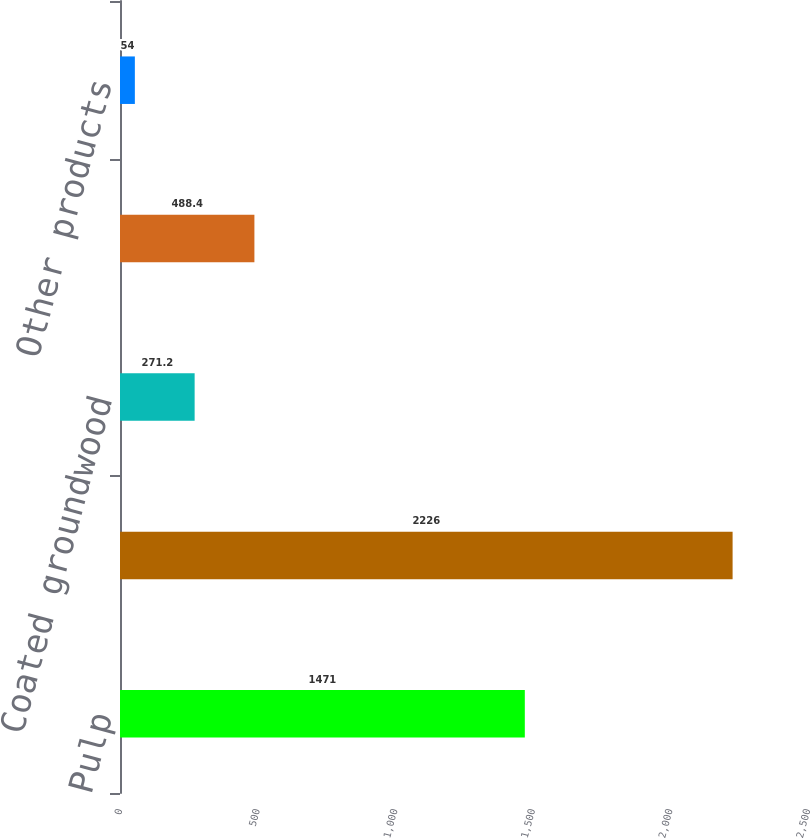Convert chart to OTSL. <chart><loc_0><loc_0><loc_500><loc_500><bar_chart><fcel>Pulp<fcel>Paper<fcel>Coated groundwood<fcel>Liquid packaging board<fcel>Other products<nl><fcel>1471<fcel>2226<fcel>271.2<fcel>488.4<fcel>54<nl></chart> 